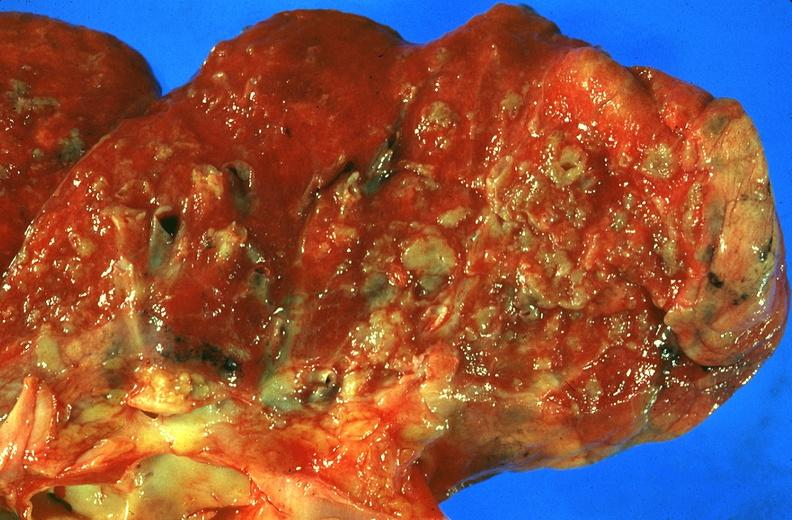where is this?
Answer the question using a single word or phrase. Lung 